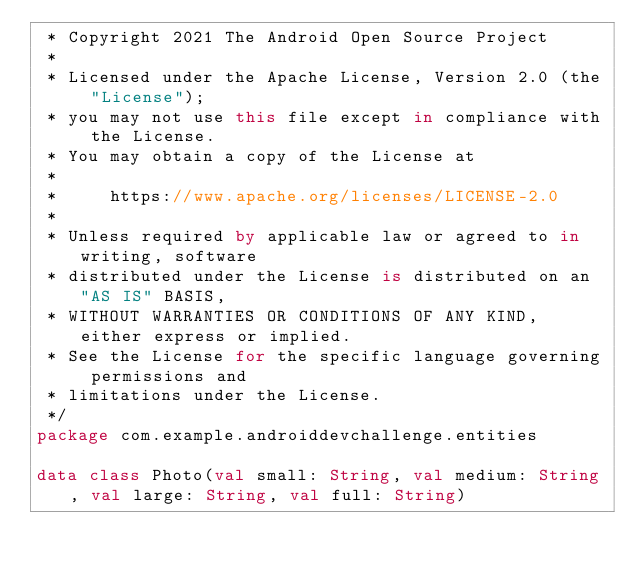<code> <loc_0><loc_0><loc_500><loc_500><_Kotlin_> * Copyright 2021 The Android Open Source Project
 *
 * Licensed under the Apache License, Version 2.0 (the "License");
 * you may not use this file except in compliance with the License.
 * You may obtain a copy of the License at
 *
 *     https://www.apache.org/licenses/LICENSE-2.0
 *
 * Unless required by applicable law or agreed to in writing, software
 * distributed under the License is distributed on an "AS IS" BASIS,
 * WITHOUT WARRANTIES OR CONDITIONS OF ANY KIND, either express or implied.
 * See the License for the specific language governing permissions and
 * limitations under the License.
 */
package com.example.androiddevchallenge.entities

data class Photo(val small: String, val medium: String, val large: String, val full: String)
</code> 